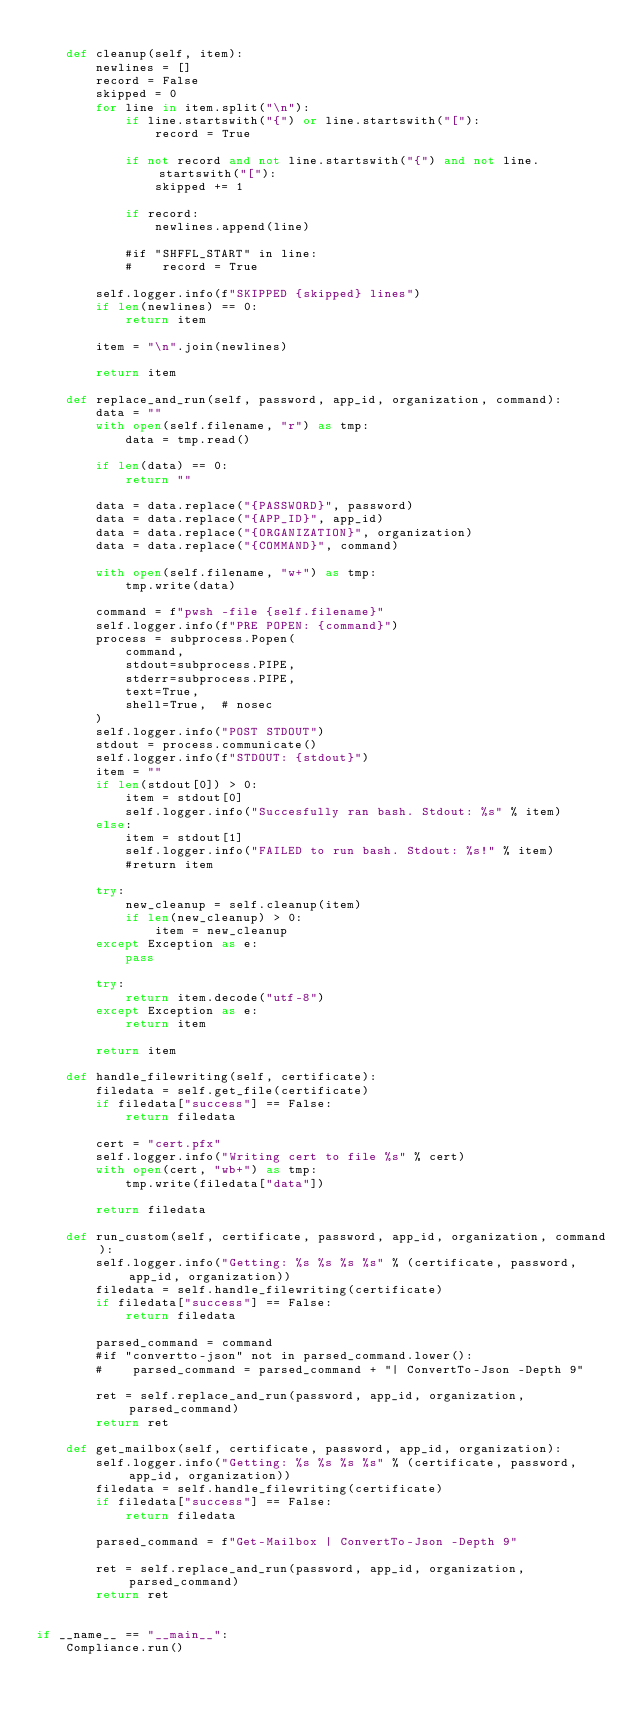<code> <loc_0><loc_0><loc_500><loc_500><_Python_>
    def cleanup(self, item):
        newlines = []
        record = False
        skipped = 0
        for line in item.split("\n"):
            if line.startswith("{") or line.startswith("["):
                record = True

            if not record and not line.startswith("{") and not line.startswith("["):
                skipped += 1
        
            if record:
                newlines.append(line)
        
            #if "SHFFL_START" in line:
            #    record = True

        self.logger.info(f"SKIPPED {skipped} lines")
        if len(newlines) == 0:
            return item

        item = "\n".join(newlines)

        return item

    def replace_and_run(self, password, app_id, organization, command):
        data = ""
        with open(self.filename, "r") as tmp:
            data = tmp.read()

        if len(data) == 0:
            return ""

        data = data.replace("{PASSWORD}", password)
        data = data.replace("{APP_ID}", app_id)
        data = data.replace("{ORGANIZATION}", organization)
        data = data.replace("{COMMAND}", command)

        with open(self.filename, "w+") as tmp:
            tmp.write(data)

        command = f"pwsh -file {self.filename}" 
        self.logger.info(f"PRE POPEN: {command}")
        process = subprocess.Popen(
            command,
            stdout=subprocess.PIPE,
            stderr=subprocess.PIPE,
            text=True,
            shell=True,  # nosec
        )
        self.logger.info("POST STDOUT")
        stdout = process.communicate()
        self.logger.info(f"STDOUT: {stdout}")
        item = ""
        if len(stdout[0]) > 0:
            item = stdout[0]
            self.logger.info("Succesfully ran bash. Stdout: %s" % item)
        else:
            item = stdout[1]
            self.logger.info("FAILED to run bash. Stdout: %s!" % item)
            #return item

        try:
            new_cleanup = self.cleanup(item)
            if len(new_cleanup) > 0:
                item = new_cleanup
        except Exception as e:
            pass

        try:
            return item.decode("utf-8")
        except Exception as e:
            return item

        return item 

    def handle_filewriting(self, certificate):
        filedata = self.get_file(certificate)
        if filedata["success"] == False:
            return filedata

        cert = "cert.pfx"
        self.logger.info("Writing cert to file %s" % cert)
        with open(cert, "wb+") as tmp:
            tmp.write(filedata["data"])

        return filedata

    def run_custom(self, certificate, password, app_id, organization, command):
        self.logger.info("Getting: %s %s %s %s" % (certificate, password, app_id, organization))
        filedata = self.handle_filewriting(certificate)
        if filedata["success"] == False:
            return filedata

        parsed_command = command
        #if "convertto-json" not in parsed_command.lower():
        #    parsed_command = parsed_command + "| ConvertTo-Json -Depth 9"

        ret = self.replace_and_run(password, app_id, organization, parsed_command)
        return ret 

    def get_mailbox(self, certificate, password, app_id, organization):
        self.logger.info("Getting: %s %s %s %s" % (certificate, password, app_id, organization))
        filedata = self.handle_filewriting(certificate)
        if filedata["success"] == False:
            return filedata

        parsed_command = f"Get-Mailbox | ConvertTo-Json -Depth 9"

        ret = self.replace_and_run(password, app_id, organization, parsed_command)
        return ret 


if __name__ == "__main__":
    Compliance.run()
</code> 